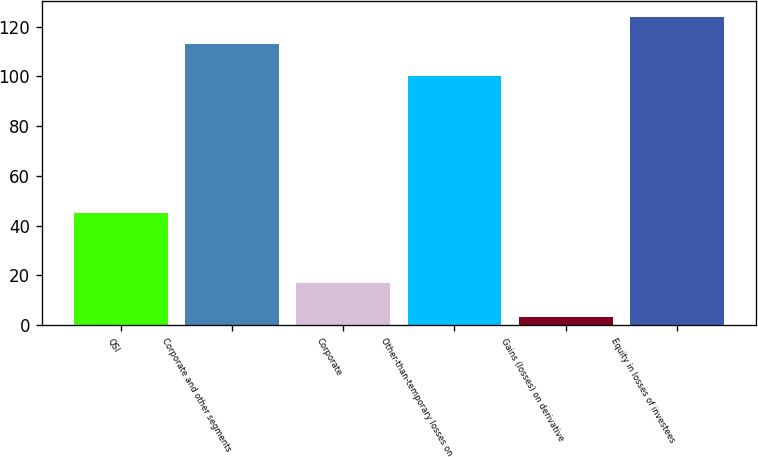Convert chart. <chart><loc_0><loc_0><loc_500><loc_500><bar_chart><fcel>QSI<fcel>Corporate and other segments<fcel>Corporate<fcel>Other-than-temporary losses on<fcel>Gains (losses) on derivative<fcel>Equity in losses of investees<nl><fcel>45<fcel>113<fcel>17<fcel>100<fcel>3<fcel>124<nl></chart> 